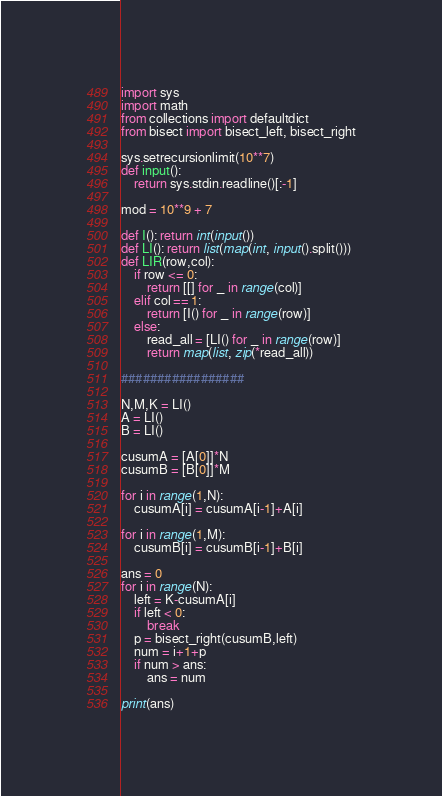<code> <loc_0><loc_0><loc_500><loc_500><_Python_>import sys
import math
from collections import defaultdict
from bisect import bisect_left, bisect_right

sys.setrecursionlimit(10**7)
def input():
    return sys.stdin.readline()[:-1]

mod = 10**9 + 7

def I(): return int(input())
def LI(): return list(map(int, input().split()))
def LIR(row,col):
    if row <= 0:
        return [[] for _ in range(col)]
    elif col == 1:
        return [I() for _ in range(row)]
    else:
        read_all = [LI() for _ in range(row)]
        return map(list, zip(*read_all))

#################

N,M,K = LI()
A = LI()
B = LI()

cusumA = [A[0]]*N
cusumB = [B[0]]*M

for i in range(1,N):
    cusumA[i] = cusumA[i-1]+A[i]

for i in range(1,M):
    cusumB[i] = cusumB[i-1]+B[i]

ans = 0
for i in range(N):
    left = K-cusumA[i]
    if left < 0:
        break
    p = bisect_right(cusumB,left)
    num = i+1+p
    if num > ans:
        ans = num

print(ans)</code> 